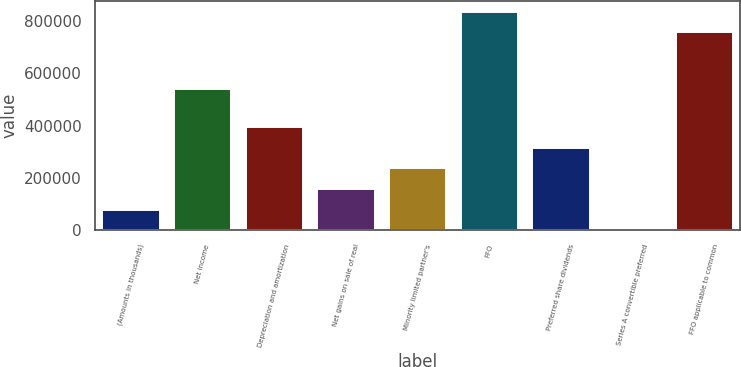<chart> <loc_0><loc_0><loc_500><loc_500><bar_chart><fcel>(Amounts in thousands)<fcel>Net income<fcel>Depreciation and amortization<fcel>Net gains on sale of real<fcel>Minority limited partner's<fcel>FFO<fcel>Preferred share dividends<fcel>Series A convertible preferred<fcel>FFO applicable to common<nl><fcel>79592.9<fcel>539604<fcel>394192<fcel>158243<fcel>236893<fcel>835869<fcel>315543<fcel>943<fcel>757219<nl></chart> 